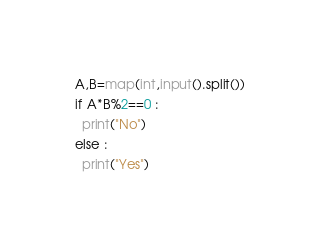Convert code to text. <code><loc_0><loc_0><loc_500><loc_500><_Python_>A,B=map(int,input().split())
if A*B%2==0 :
  print("No")
else :
  print("Yes")</code> 